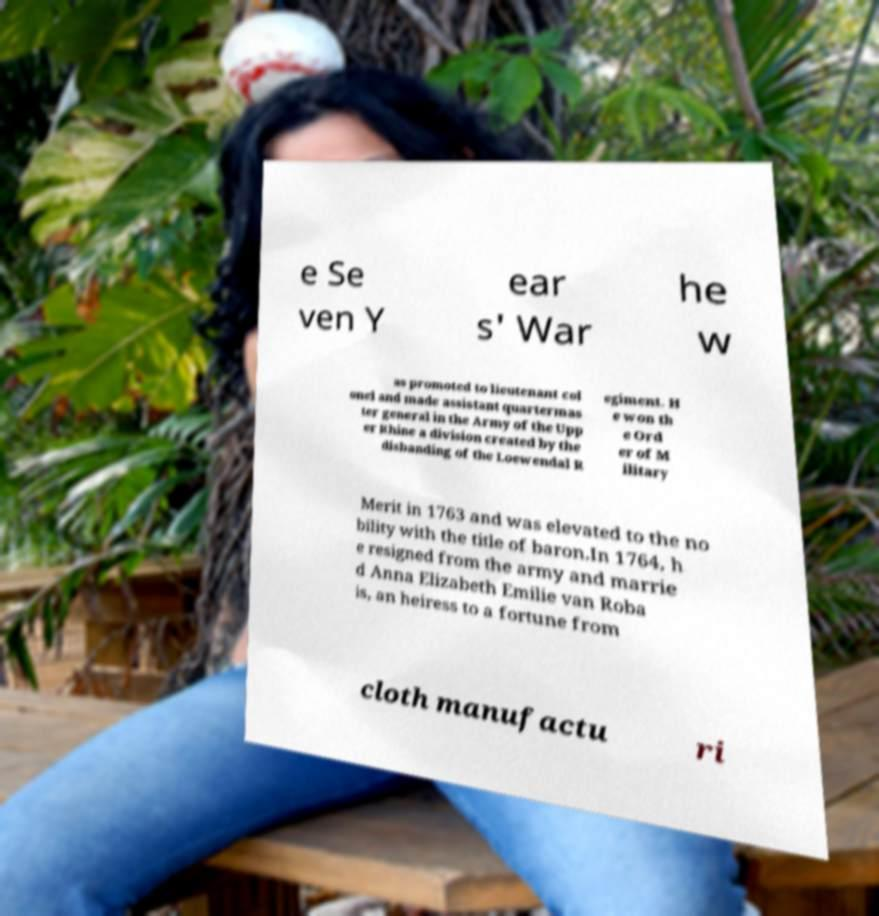Can you read and provide the text displayed in the image?This photo seems to have some interesting text. Can you extract and type it out for me? e Se ven Y ear s' War he w as promoted to lieutenant col onel and made assistant quartermas ter general in the Army of the Upp er Rhine a division created by the disbanding of the Loewendal R egiment. H e won th e Ord er of M ilitary Merit in 1763 and was elevated to the no bility with the title of baron.In 1764, h e resigned from the army and marrie d Anna Elizabeth Emilie van Roba is, an heiress to a fortune from cloth manufactu ri 